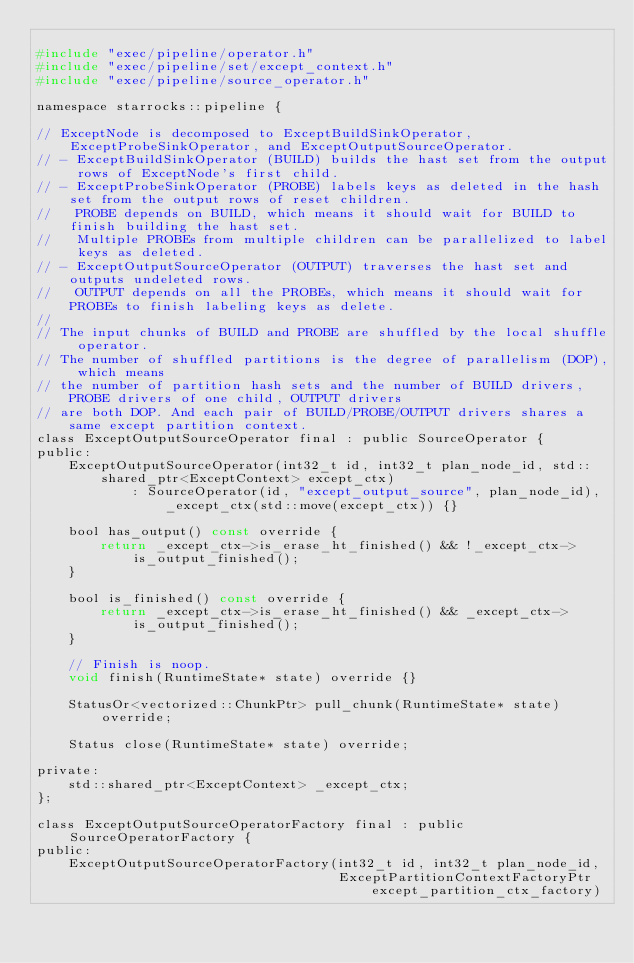Convert code to text. <code><loc_0><loc_0><loc_500><loc_500><_C_>
#include "exec/pipeline/operator.h"
#include "exec/pipeline/set/except_context.h"
#include "exec/pipeline/source_operator.h"

namespace starrocks::pipeline {

// ExceptNode is decomposed to ExceptBuildSinkOperator, ExceptProbeSinkOperator, and ExceptOutputSourceOperator.
// - ExceptBuildSinkOperator (BUILD) builds the hast set from the output rows of ExceptNode's first child.
// - ExceptProbeSinkOperator (PROBE) labels keys as deleted in the hash set from the output rows of reset children.
//   PROBE depends on BUILD, which means it should wait for BUILD to finish building the hast set.
//   Multiple PROBEs from multiple children can be parallelized to label keys as deleted.
// - ExceptOutputSourceOperator (OUTPUT) traverses the hast set and outputs undeleted rows.
//   OUTPUT depends on all the PROBEs, which means it should wait for PROBEs to finish labeling keys as delete.
//
// The input chunks of BUILD and PROBE are shuffled by the local shuffle operator.
// The number of shuffled partitions is the degree of parallelism (DOP), which means
// the number of partition hash sets and the number of BUILD drivers, PROBE drivers of one child, OUTPUT drivers
// are both DOP. And each pair of BUILD/PROBE/OUTPUT drivers shares a same except partition context.
class ExceptOutputSourceOperator final : public SourceOperator {
public:
    ExceptOutputSourceOperator(int32_t id, int32_t plan_node_id, std::shared_ptr<ExceptContext> except_ctx)
            : SourceOperator(id, "except_output_source", plan_node_id), _except_ctx(std::move(except_ctx)) {}

    bool has_output() const override {
        return _except_ctx->is_erase_ht_finished() && !_except_ctx->is_output_finished();
    }

    bool is_finished() const override {
        return _except_ctx->is_erase_ht_finished() && _except_ctx->is_output_finished();
    }

    // Finish is noop.
    void finish(RuntimeState* state) override {}

    StatusOr<vectorized::ChunkPtr> pull_chunk(RuntimeState* state) override;

    Status close(RuntimeState* state) override;

private:
    std::shared_ptr<ExceptContext> _except_ctx;
};

class ExceptOutputSourceOperatorFactory final : public SourceOperatorFactory {
public:
    ExceptOutputSourceOperatorFactory(int32_t id, int32_t plan_node_id,
                                      ExceptPartitionContextFactoryPtr except_partition_ctx_factory)</code> 